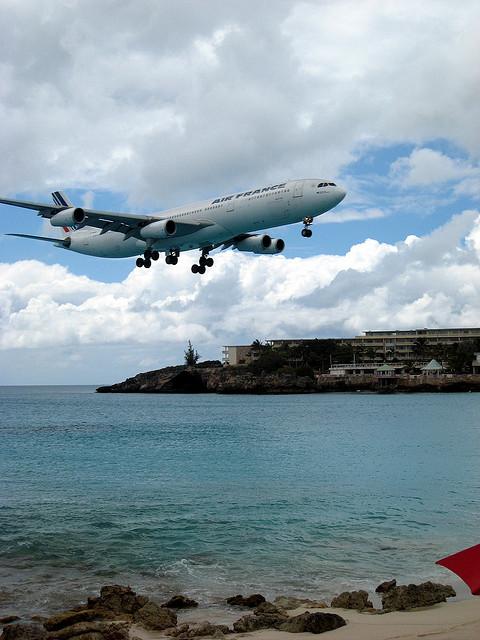Is this a military aircraft?
Keep it brief. No. What method of transportation is shown?
Write a very short answer. Airplane. What color is the water?
Be succinct. Blue. Is the airplane landing or taking off?
Be succinct. Landing. Where is the plane?
Write a very short answer. In air. What is laying on the ground in the foreground?
Answer briefly. Rocks. Is this a big plane?
Be succinct. Yes. 